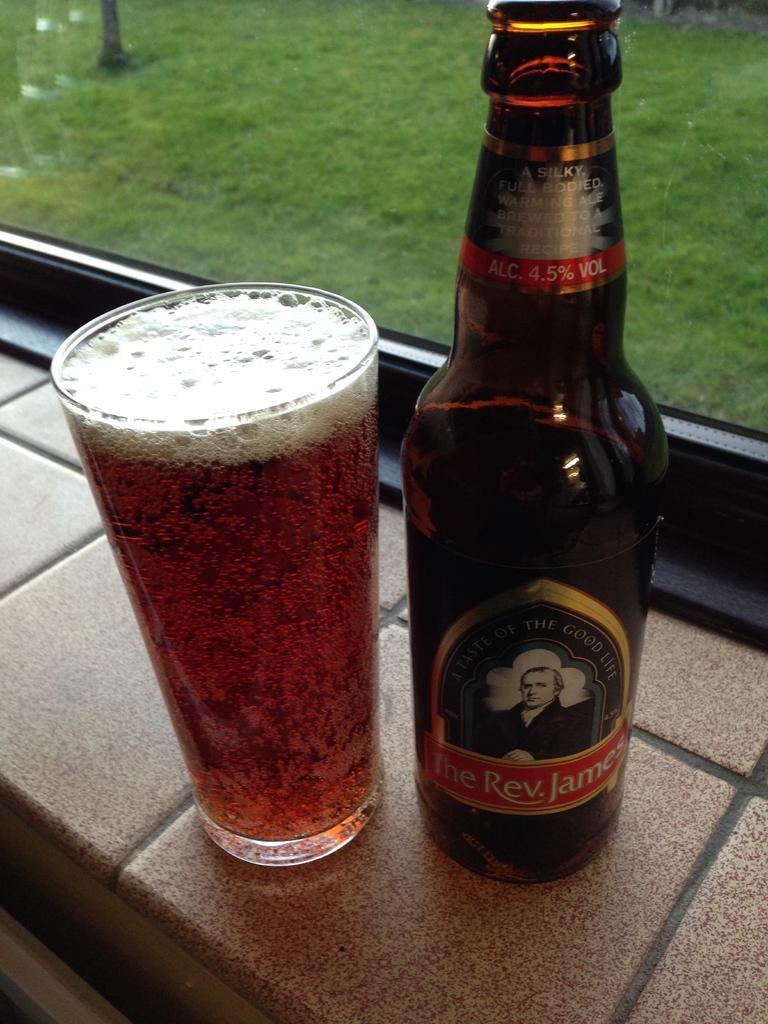Please provide a concise description of this image. In this image, I can see a glass of beer and a beer bottle are placed on the wall. In the background, I can see the grass through the transparent glass window. 